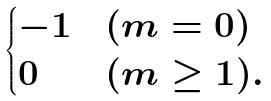Convert formula to latex. <formula><loc_0><loc_0><loc_500><loc_500>\begin{cases} - 1 & ( m = 0 ) \\ 0 & ( m \geq 1 ) . \end{cases}</formula> 